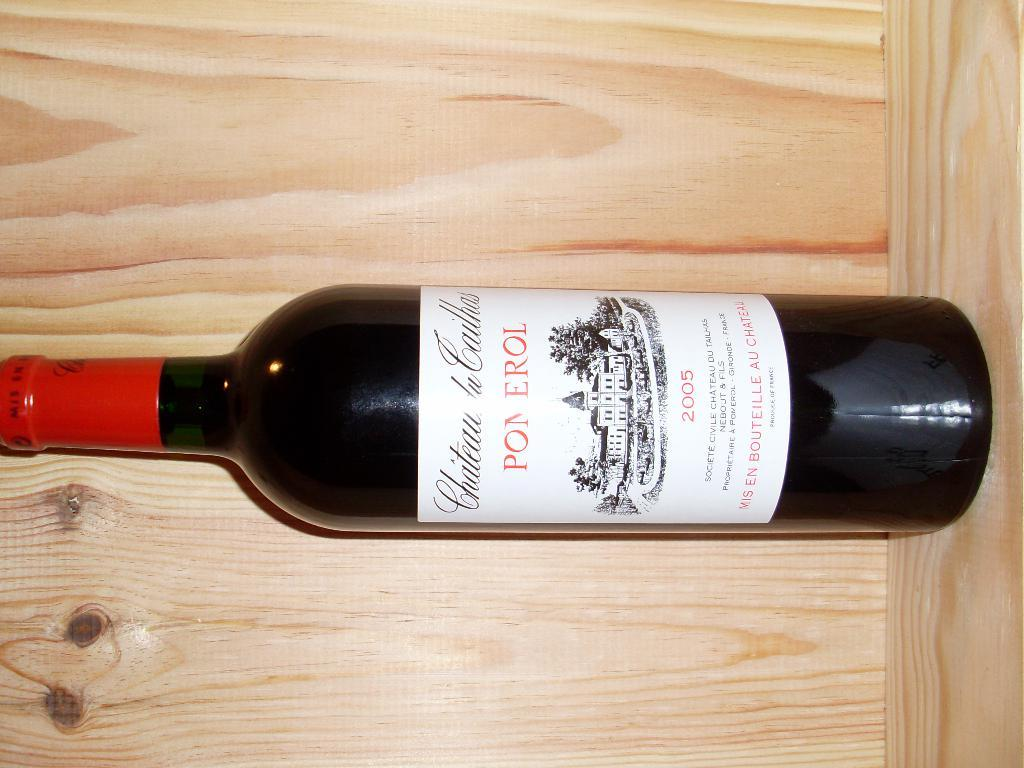<image>
Summarize the visual content of the image. A bottle of Pom Erol wine with a red label on the top. 